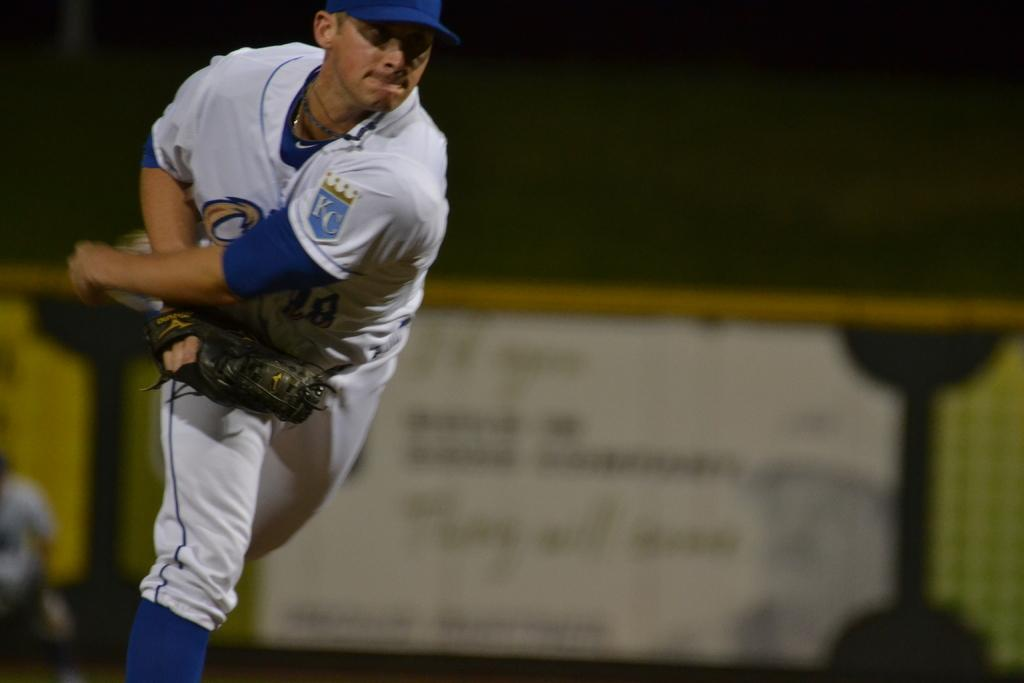<image>
Share a concise interpretation of the image provided. A pitcher for the Kansas City Royals is at the pitcher's mound, and from his stance appears that he has just pitched the ball. 